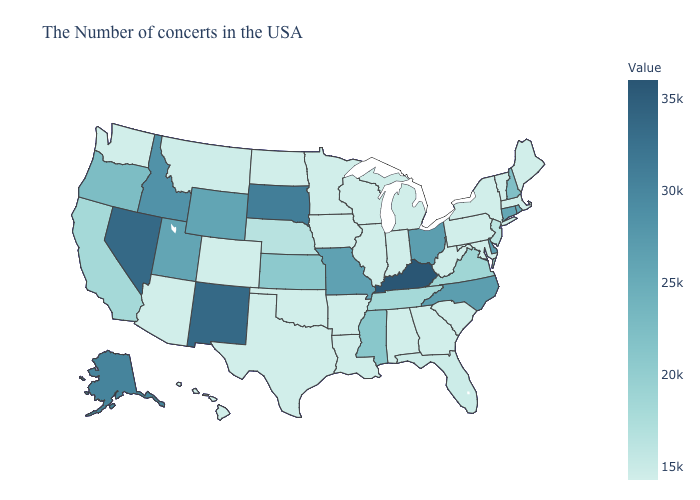Does Oregon have a lower value than Illinois?
Answer briefly. No. Which states have the highest value in the USA?
Be succinct. Kentucky. Is the legend a continuous bar?
Write a very short answer. Yes. Which states have the lowest value in the USA?
Concise answer only. Maine, Massachusetts, Vermont, New York, Maryland, Pennsylvania, South Carolina, West Virginia, Georgia, Michigan, Indiana, Alabama, Wisconsin, Illinois, Louisiana, Arkansas, Minnesota, Iowa, Oklahoma, Texas, North Dakota, Colorado, Arizona, Washington, Hawaii. Does South Dakota have the highest value in the MidWest?
Answer briefly. Yes. Does New York have the highest value in the USA?
Concise answer only. No. Does Rhode Island have the highest value in the USA?
Give a very brief answer. No. Does Minnesota have a lower value than Kentucky?
Concise answer only. Yes. Which states have the lowest value in the West?
Short answer required. Colorado, Arizona, Washington, Hawaii. Which states have the highest value in the USA?
Concise answer only. Kentucky. 